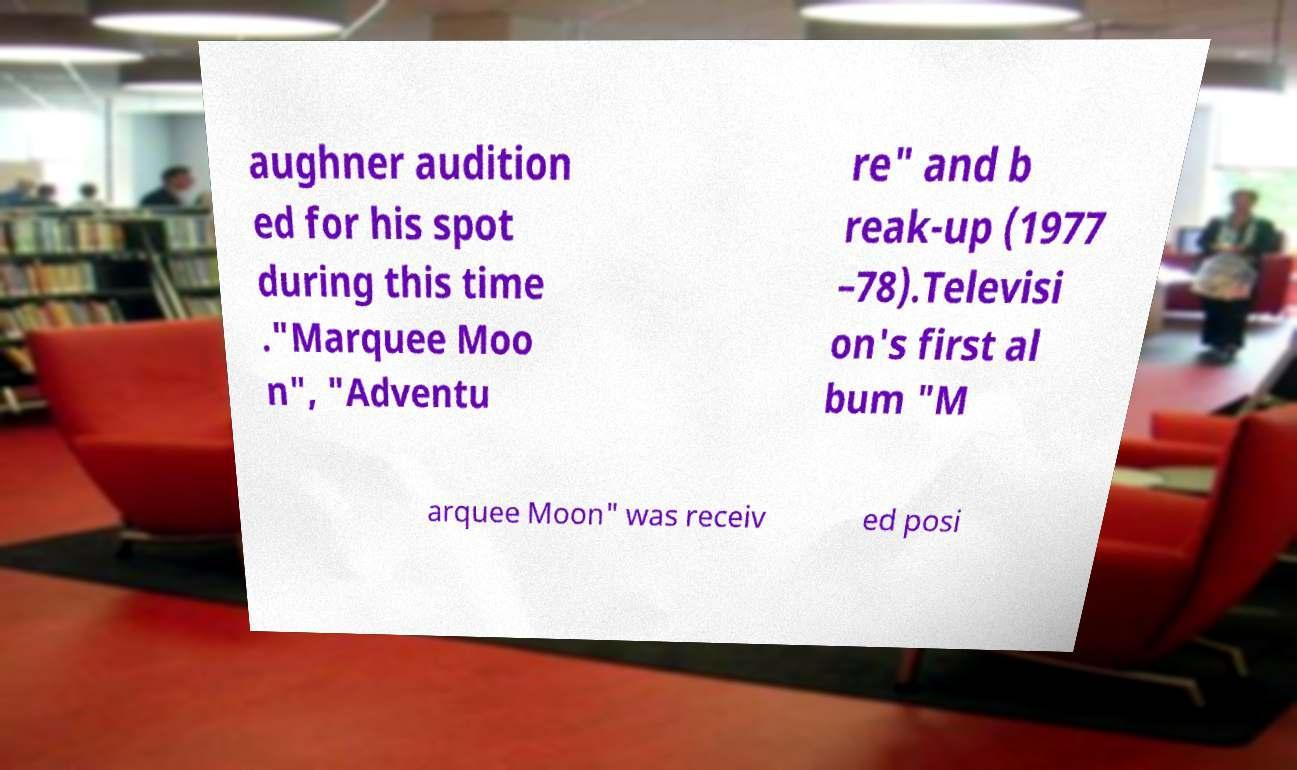There's text embedded in this image that I need extracted. Can you transcribe it verbatim? aughner audition ed for his spot during this time ."Marquee Moo n", "Adventu re" and b reak-up (1977 –78).Televisi on's first al bum "M arquee Moon" was receiv ed posi 